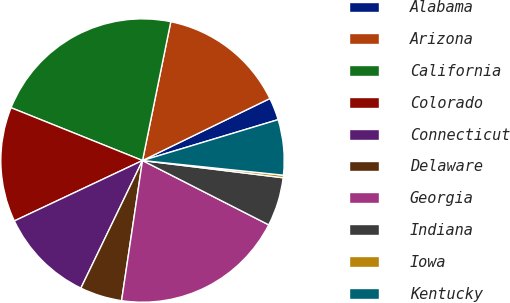<chart> <loc_0><loc_0><loc_500><loc_500><pie_chart><fcel>Alabama<fcel>Arizona<fcel>California<fcel>Colorado<fcel>Connecticut<fcel>Delaware<fcel>Georgia<fcel>Indiana<fcel>Iowa<fcel>Kentucky<nl><fcel>2.55%<fcel>14.59%<fcel>22.12%<fcel>13.09%<fcel>10.83%<fcel>4.8%<fcel>19.86%<fcel>5.56%<fcel>0.29%<fcel>6.31%<nl></chart> 